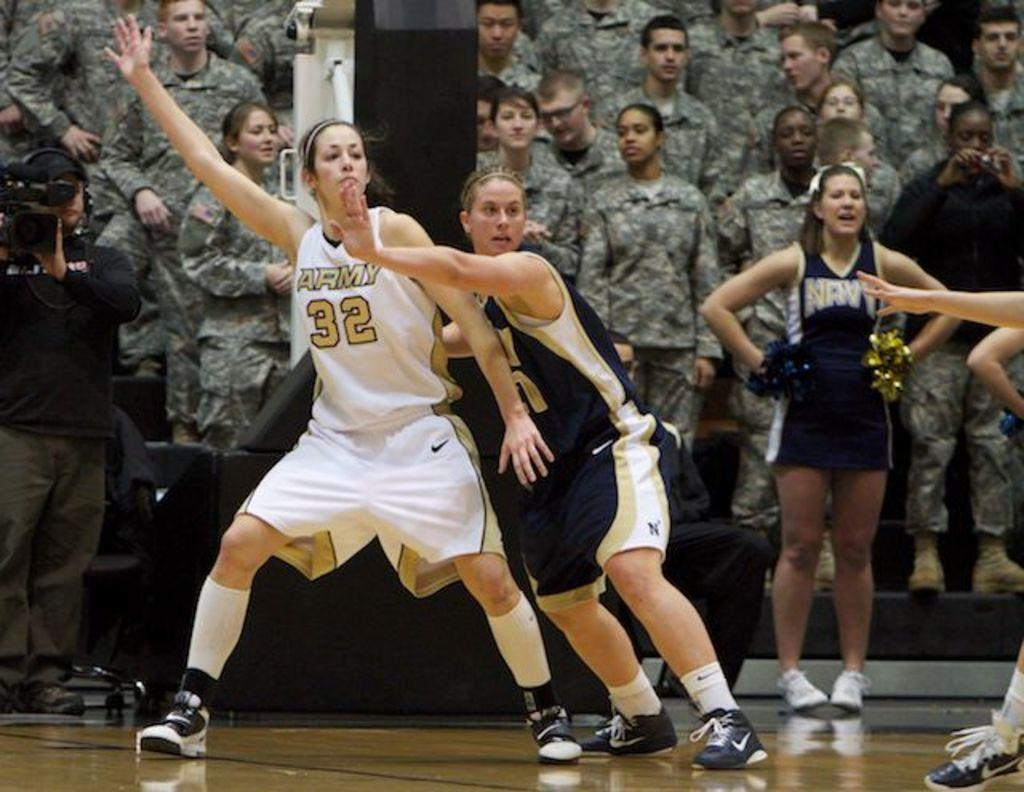Provide a one-sentence caption for the provided image. Women playing basketball, one with 32 on her shirt, in front of an audience of soldiers. 